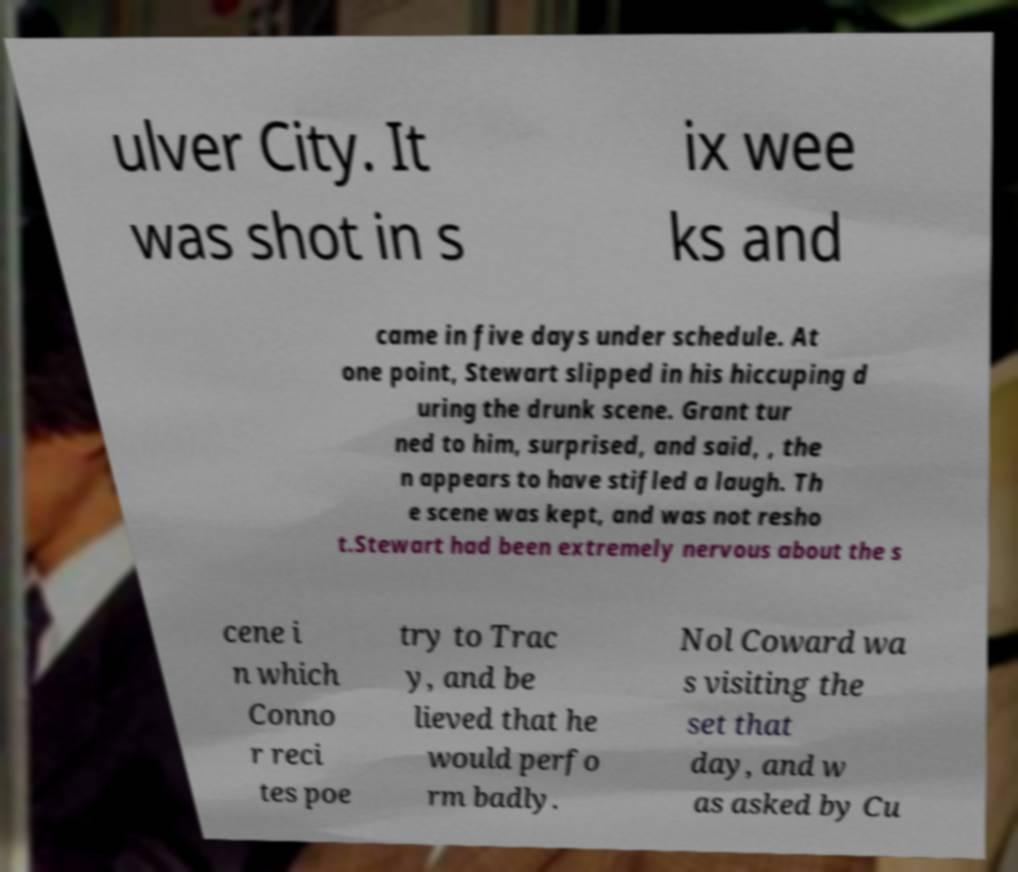Could you assist in decoding the text presented in this image and type it out clearly? ulver City. It was shot in s ix wee ks and came in five days under schedule. At one point, Stewart slipped in his hiccuping d uring the drunk scene. Grant tur ned to him, surprised, and said, , the n appears to have stifled a laugh. Th e scene was kept, and was not resho t.Stewart had been extremely nervous about the s cene i n which Conno r reci tes poe try to Trac y, and be lieved that he would perfo rm badly. Nol Coward wa s visiting the set that day, and w as asked by Cu 